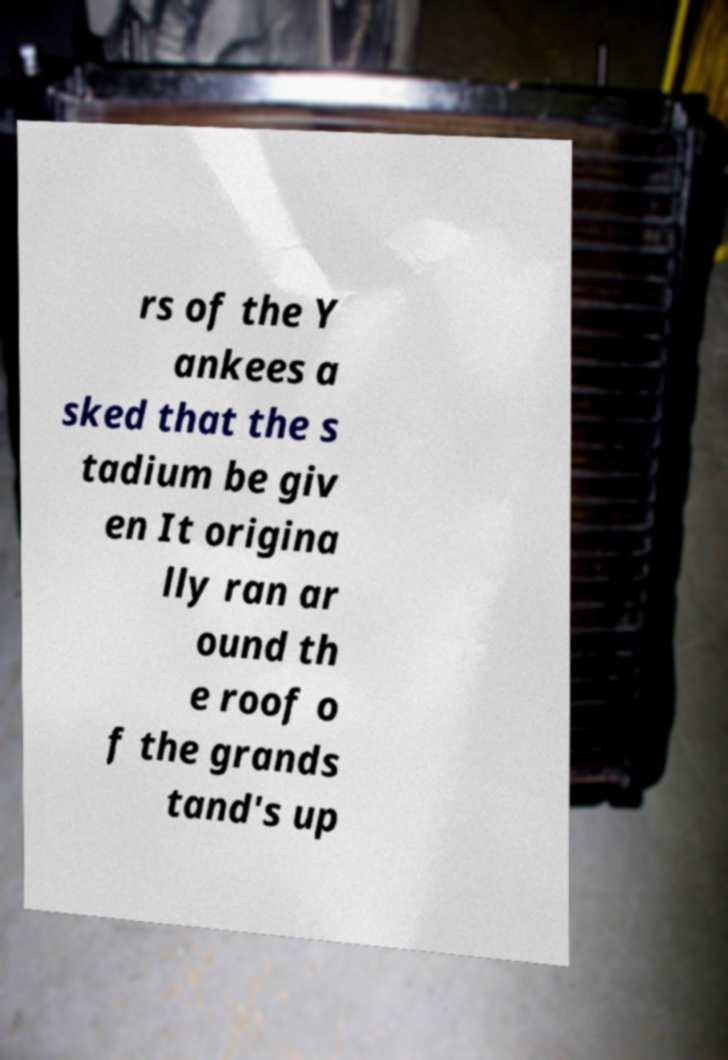Please identify and transcribe the text found in this image. rs of the Y ankees a sked that the s tadium be giv en It origina lly ran ar ound th e roof o f the grands tand's up 